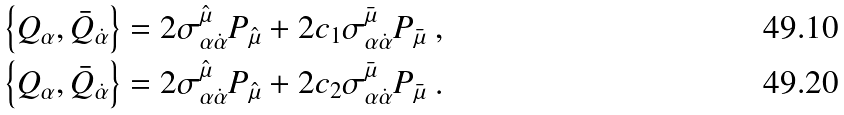Convert formula to latex. <formula><loc_0><loc_0><loc_500><loc_500>& \left \{ Q _ { \alpha } , \bar { Q } _ { \dot { \alpha } } \right \} = 2 \sigma ^ { \hat { \mu } } _ { \alpha \dot { \alpha } } P _ { \hat { \mu } } + 2 c _ { 1 } \sigma ^ { \bar { \mu } } _ { \alpha \dot { \alpha } } P _ { \bar { \mu } } \ , \\ & \left \{ Q _ { \alpha } , \bar { Q } _ { \dot { \alpha } } \right \} = 2 \sigma ^ { \hat { \mu } } _ { \alpha \dot { \alpha } } P _ { \hat { \mu } } + 2 c _ { 2 } \sigma ^ { \bar { \mu } } _ { \alpha \dot { \alpha } } P _ { \bar { \mu } } \ .</formula> 